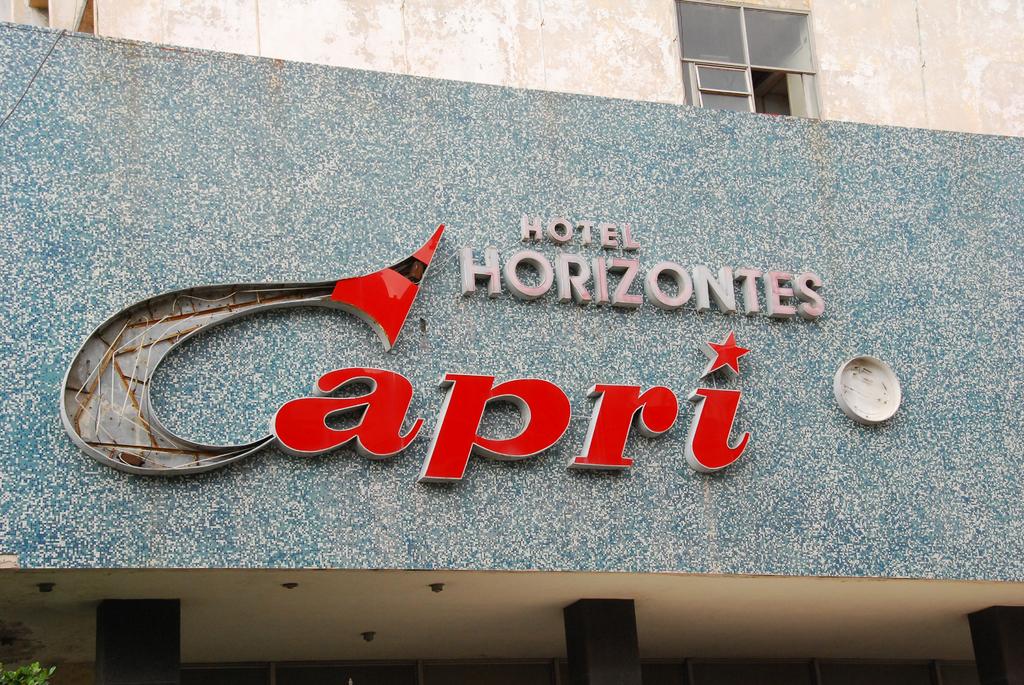What is the name of the hotel?
Provide a succinct answer. Hotel horizontes capri. What type of business is advertised?
Offer a very short reply. Hotel. 